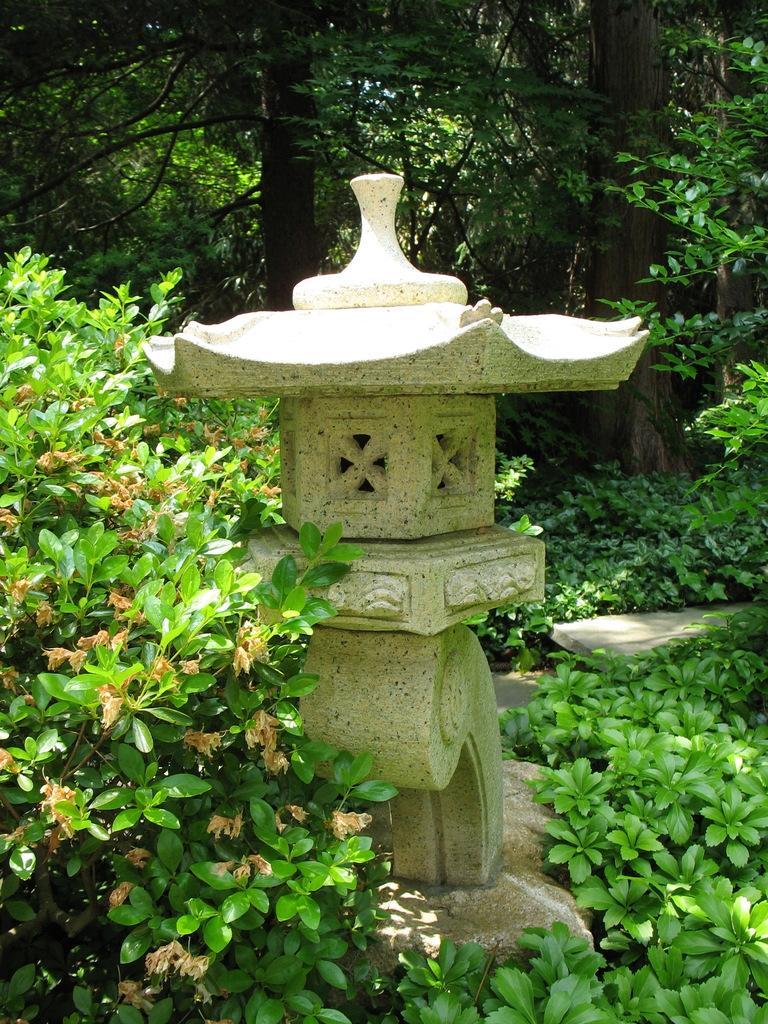Describe this image in one or two sentences. In this image we can see a statue placed on the ground. In the background, we can see group of trees and plants. 